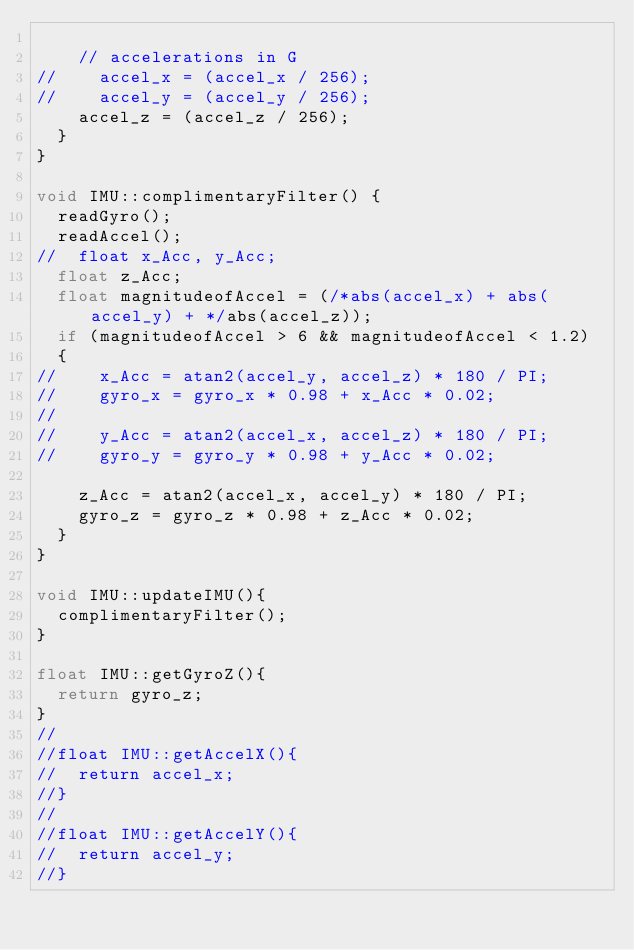Convert code to text. <code><loc_0><loc_0><loc_500><loc_500><_C++_>
    // accelerations in G
//    accel_x = (accel_x / 256);
//    accel_y = (accel_y / 256);
    accel_z = (accel_z / 256);
  }
}

void IMU::complimentaryFilter() {
  readGyro();
  readAccel();
//  float x_Acc, y_Acc;
  float z_Acc;
  float magnitudeofAccel = (/*abs(accel_x) + abs(accel_y) + */abs(accel_z));
  if (magnitudeofAccel > 6 && magnitudeofAccel < 1.2)
  {
//    x_Acc = atan2(accel_y, accel_z) * 180 / PI;
//    gyro_x = gyro_x * 0.98 + x_Acc * 0.02;
//
//    y_Acc = atan2(accel_x, accel_z) * 180 / PI;
//    gyro_y = gyro_y * 0.98 + y_Acc * 0.02;

    z_Acc = atan2(accel_x, accel_y) * 180 / PI;
    gyro_z = gyro_z * 0.98 + z_Acc * 0.02;
  }
}

void IMU::updateIMU(){
  complimentaryFilter();
}

float IMU::getGyroZ(){
  return gyro_z;
}
//
//float IMU::getAccelX(){
//  return accel_x;
//}
//
//float IMU::getAccelY(){
//  return accel_y;
//}



</code> 